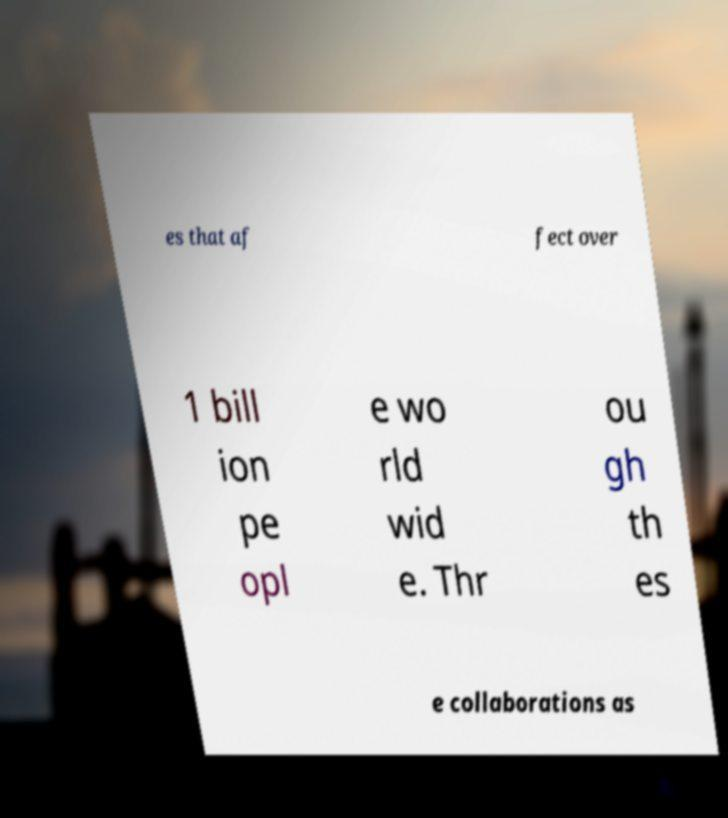For documentation purposes, I need the text within this image transcribed. Could you provide that? es that af fect over 1 bill ion pe opl e wo rld wid e. Thr ou gh th es e collaborations as 